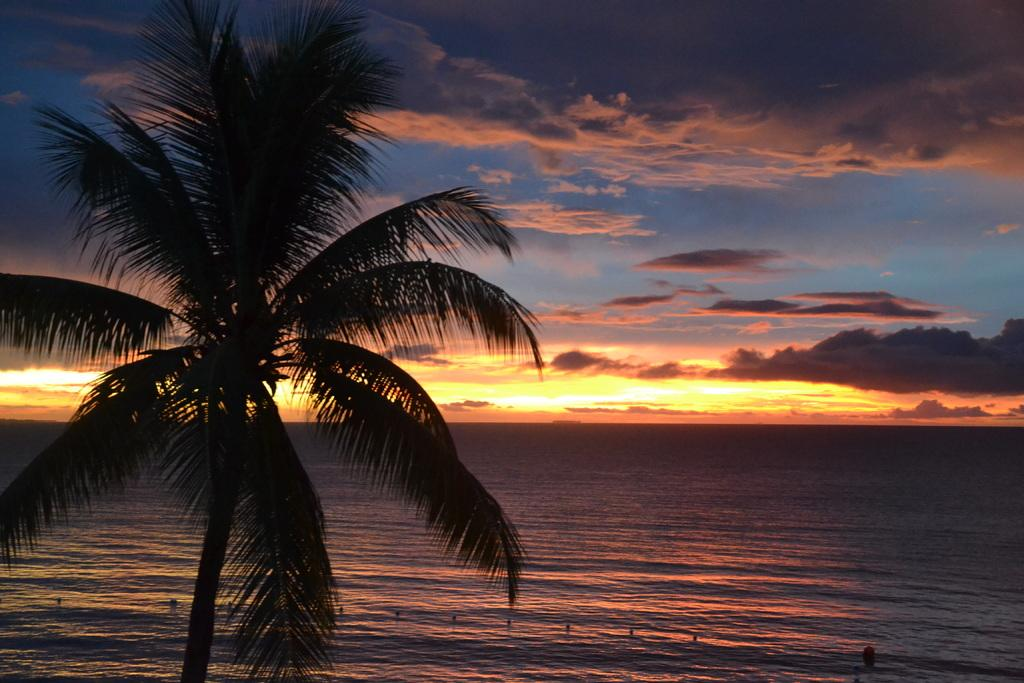What is located on the left side of the image? There is a tree on the left side of the image. What natural feature is depicted in the middle of the image? There is a sea in the middle of the image. What is visible at the top of the image? The sky is visible at the top of the image. How would you describe the sky in the image? The sky appears to be cloudy. What color is the orange hanging from the tree in the image? There is no orange present in the image; it features a tree, sea, and cloudy sky. What type of wire can be seen connecting the clouds in the image? There is no wire present in the image; it only shows a tree, sea, and cloudy sky. 